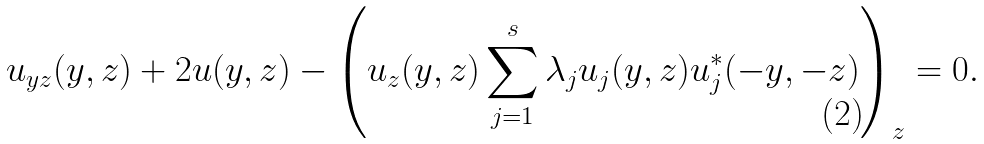Convert formula to latex. <formula><loc_0><loc_0><loc_500><loc_500>u _ { y z } ( y , z ) + 2 u ( y , z ) - \left ( u _ { z } ( y , z ) \sum ^ { s } _ { j = 1 } \lambda _ { j } u _ { j } ( y , z ) u _ { j } ^ { * } ( - y , - z ) \right ) _ { z } = 0 .</formula> 